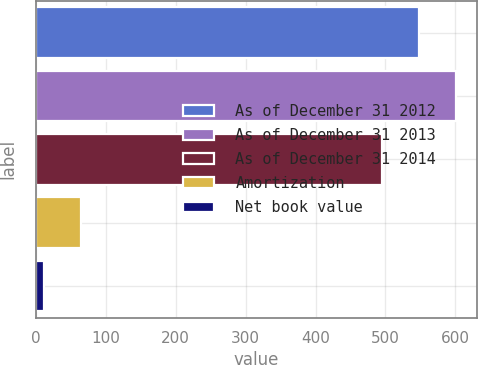Convert chart to OTSL. <chart><loc_0><loc_0><loc_500><loc_500><bar_chart><fcel>As of December 31 2012<fcel>As of December 31 2013<fcel>As of December 31 2014<fcel>Amortization<fcel>Net book value<nl><fcel>548.2<fcel>601.4<fcel>495<fcel>65.2<fcel>12<nl></chart> 